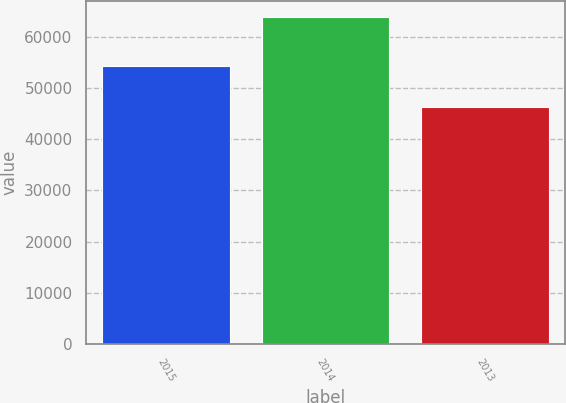Convert chart to OTSL. <chart><loc_0><loc_0><loc_500><loc_500><bar_chart><fcel>2015<fcel>2014<fcel>2013<nl><fcel>54219<fcel>63842<fcel>46208<nl></chart> 